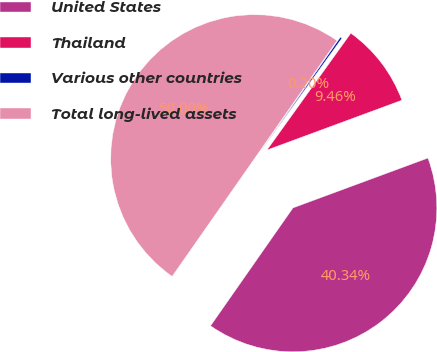<chart> <loc_0><loc_0><loc_500><loc_500><pie_chart><fcel>United States<fcel>Thailand<fcel>Various other countries<fcel>Total long-lived assets<nl><fcel>40.34%<fcel>9.46%<fcel>0.2%<fcel>50.0%<nl></chart> 